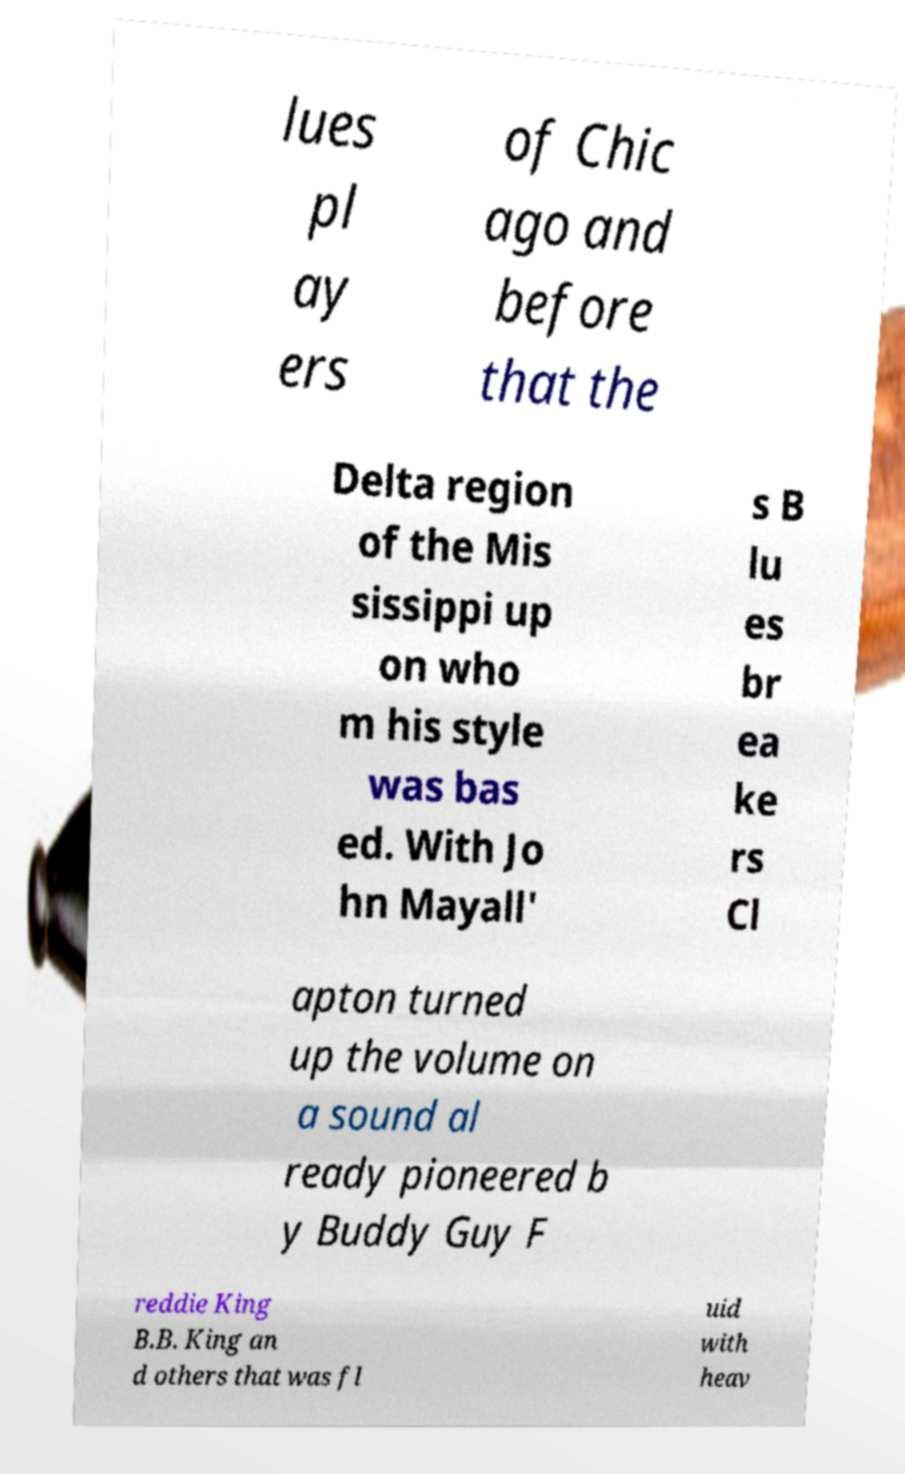Can you accurately transcribe the text from the provided image for me? lues pl ay ers of Chic ago and before that the Delta region of the Mis sissippi up on who m his style was bas ed. With Jo hn Mayall' s B lu es br ea ke rs Cl apton turned up the volume on a sound al ready pioneered b y Buddy Guy F reddie King B.B. King an d others that was fl uid with heav 